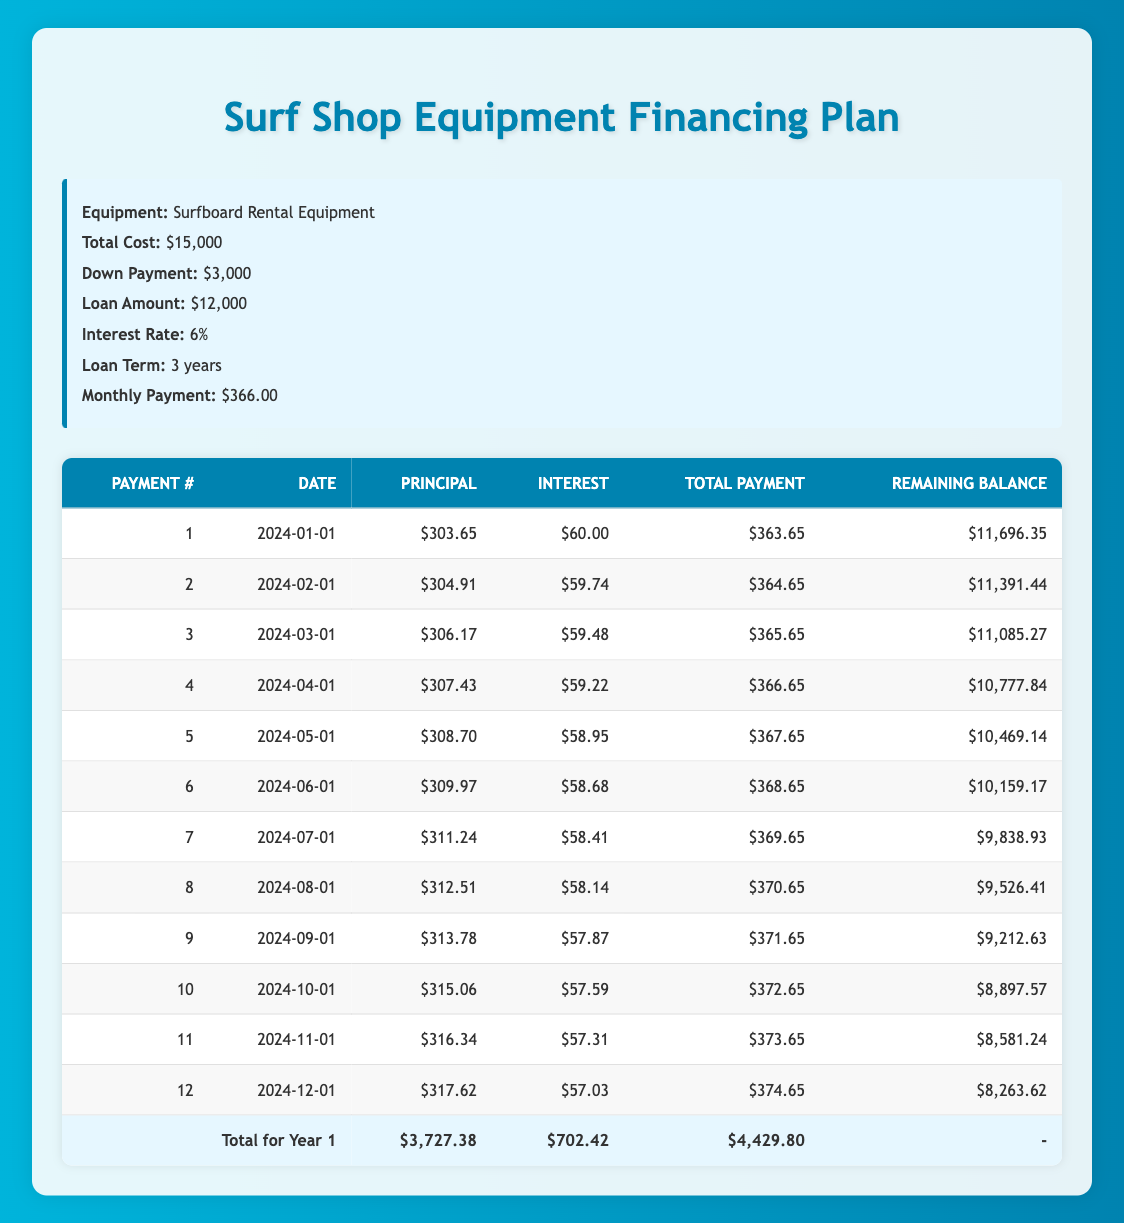What is the total monthly payment for the surfboard rental equipment? The total monthly payment is listed directly in the info box of the table, which states it is $366.00.
Answer: 366.00 On which date is the first payment due? The payment schedule lists the first payment date as "2024-01-01."
Answer: 2024-01-01 What is the remaining balance after the 6th payment? The remaining balance after the 6th payment can be found in the payment schedule next to payment number 6, which indicates it is $10,159.17.
Answer: 10,159.17 How much did I pay in principal over the first year? To find out the total principal paid in the first year, we sum the principal payments for payments 1 through 12: (303.65 + 304.91 + 306.17 + 307.43 + 308.70 + 309.97 + 311.24 + 312.51 + 313.78 + 315.06 + 316.34 + 317.62) = $3,727.38.
Answer: 3,727.38 Is the interest payment for the second payment greater than the interest payment for the first payment? The interest payment for the first payment is $60.00, and the second payment is $59.74. Since $60.00 is greater than $59.74, the answer is yes.
Answer: Yes What is the difference in principal payments between the 5th and 10th payments? The principal payment for the 5th payment is $308.70 and for the 10th payment it is $315.06. The difference is calculated as $315.06 - $308.70 = $6.36.
Answer: 6.36 What is the total interest paid in the first year? To calculate the total interest paid in the first year, we can sum the interest payments from each of the first 12 months: (60.00 + 59.74 + 59.48 + 59.22 + 58.95 + 58.68 + 58.41 + 58.14 + 57.87 + 57.59 + 57.31 + 57.03) = $702.42.
Answer: 702.42 Which payment has the lowest total payment? The total payment for each month can be compared, and the lowest total payment is for payment number 1, which is $363.65.
Answer: 363.65 How much will be paid in total after the first year? To find the total amount paid after the first year, we multiply the monthly payment by 12: $366.00 * 12 = $4,392.00.
Answer: 4,392.00 